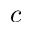<formula> <loc_0><loc_0><loc_500><loc_500>c</formula> 